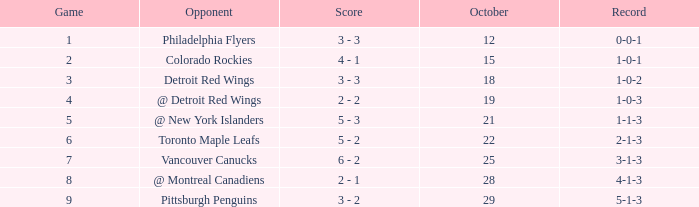Name the least game for record of 1-0-2 3.0. 